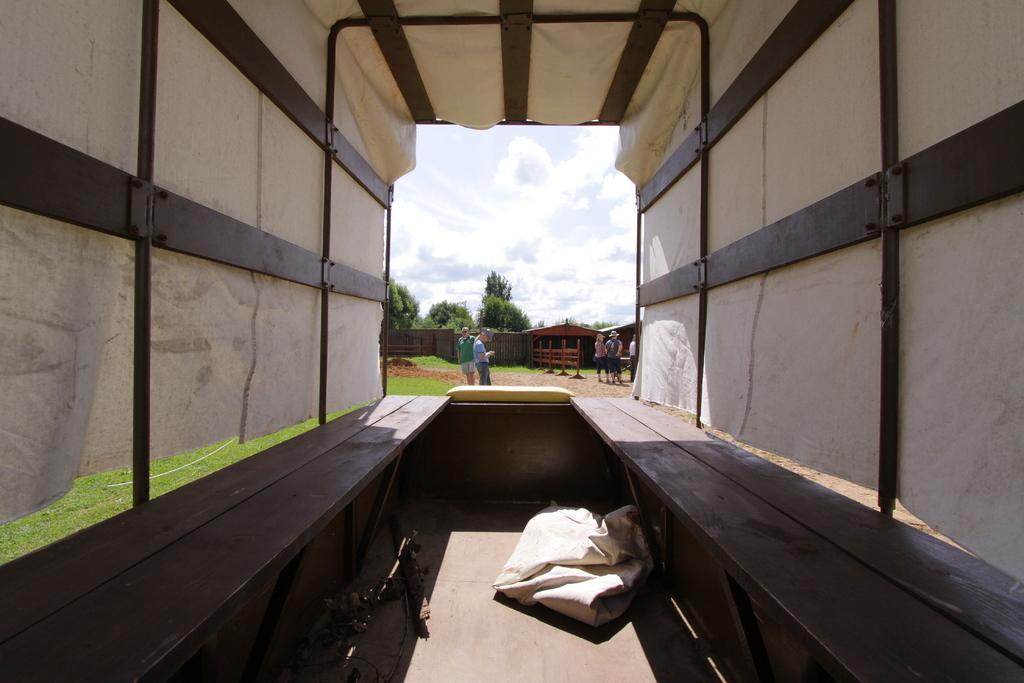Describe this image in one or two sentences. In this I can see it looks like an inside part of a vehicle. In the middle there are few people, at the back side there are trees. At the top it is the sky. 